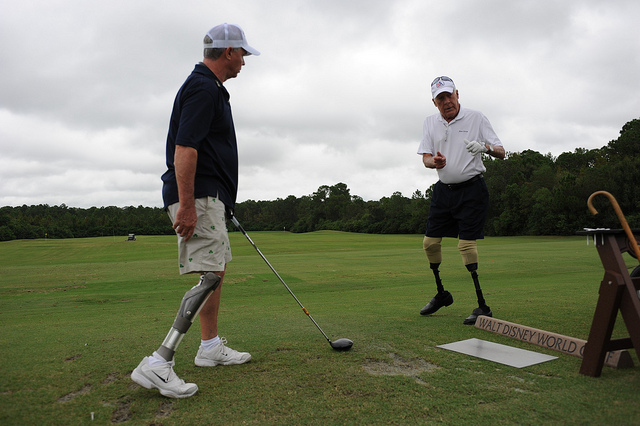Please transcribe the text in this image. WALT DISNEY WORLD F 